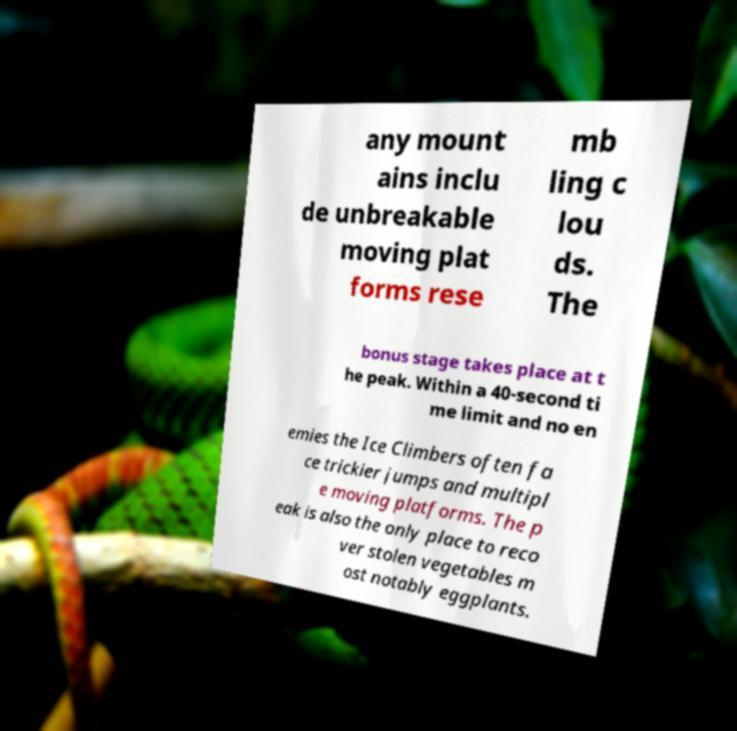Can you accurately transcribe the text from the provided image for me? any mount ains inclu de unbreakable moving plat forms rese mb ling c lou ds. The bonus stage takes place at t he peak. Within a 40-second ti me limit and no en emies the Ice Climbers often fa ce trickier jumps and multipl e moving platforms. The p eak is also the only place to reco ver stolen vegetables m ost notably eggplants. 